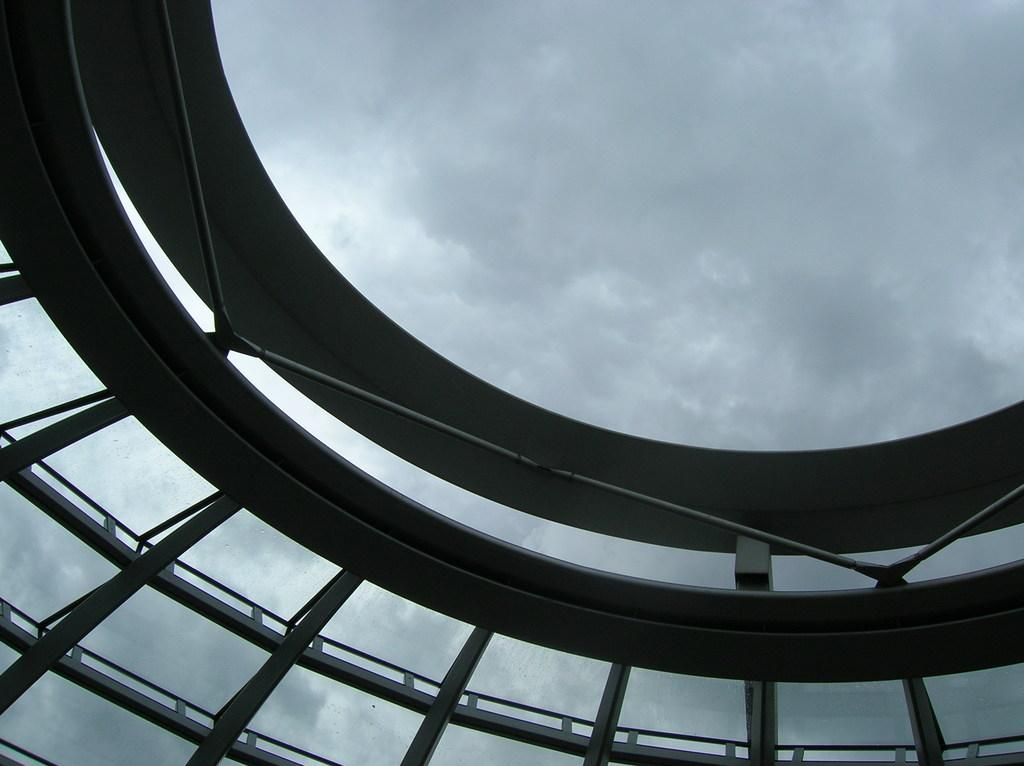What structure is the main focus of the image? There is a dome in the image. What can be seen in the background of the image? The sky is visible in the background of the image. How would you describe the sky in the image? The sky appears to be cloudy. What type of bushes can be seen growing around the dome in the image? There are no bushes visible in the image; the focus is on the dome and the cloudy sky. 